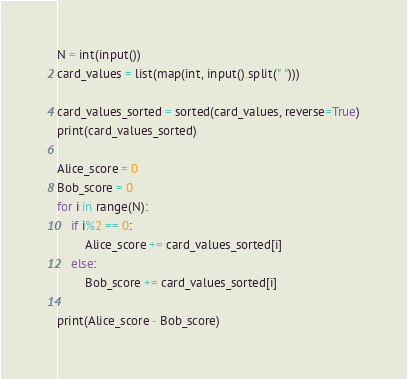<code> <loc_0><loc_0><loc_500><loc_500><_Python_>N = int(input())
card_values = list(map(int, input().split(" ")))

card_values_sorted = sorted(card_values, reverse=True)
print(card_values_sorted)

Alice_score = 0
Bob_score = 0
for i in range(N):
    if i%2 == 0:
        Alice_score += card_values_sorted[i]
    else:
        Bob_score += card_values_sorted[i]

print(Alice_score - Bob_score)</code> 